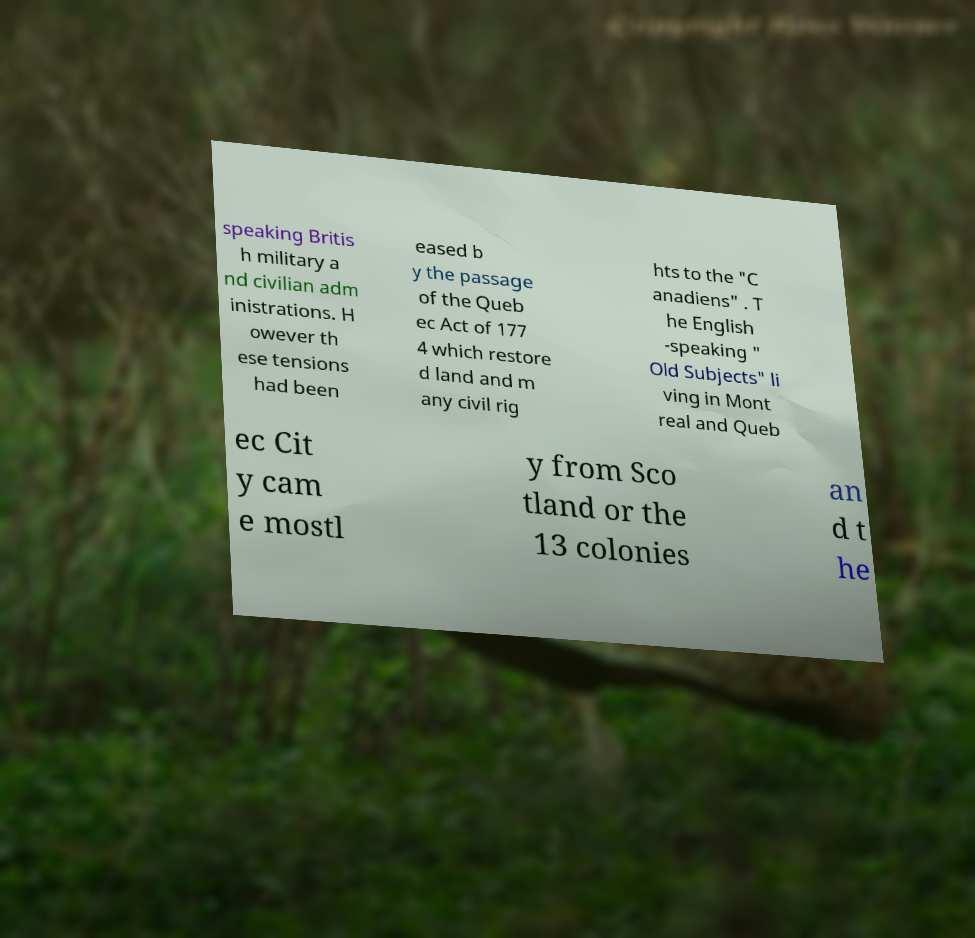Please read and relay the text visible in this image. What does it say? speaking Britis h military a nd civilian adm inistrations. H owever th ese tensions had been eased b y the passage of the Queb ec Act of 177 4 which restore d land and m any civil rig hts to the "C anadiens" . T he English -speaking " Old Subjects" li ving in Mont real and Queb ec Cit y cam e mostl y from Sco tland or the 13 colonies an d t he 